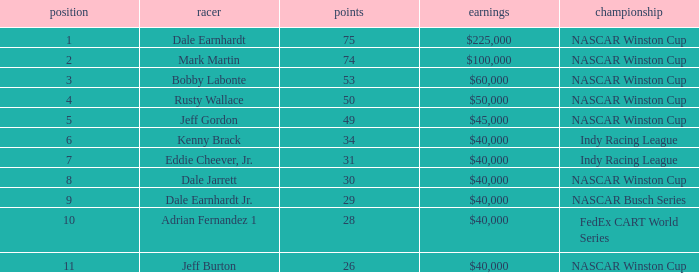In what series did Bobby Labonte drive? NASCAR Winston Cup. 